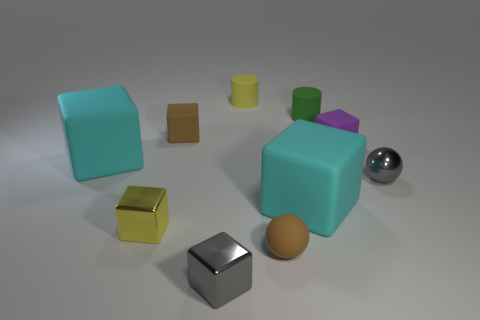Subtract all tiny gray metal cubes. How many cubes are left? 5 Subtract all cyan blocks. How many blocks are left? 4 Add 5 small brown objects. How many small brown objects exist? 7 Subtract 0 red cubes. How many objects are left? 10 Subtract all balls. How many objects are left? 8 Subtract 1 blocks. How many blocks are left? 5 Subtract all green blocks. Subtract all yellow cylinders. How many blocks are left? 6 Subtract all gray cylinders. How many red blocks are left? 0 Subtract all big gray metallic blocks. Subtract all small gray metal spheres. How many objects are left? 9 Add 5 rubber cylinders. How many rubber cylinders are left? 7 